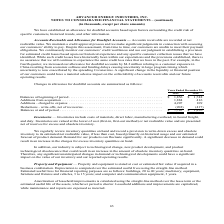According to Advanced Energy's financial document, What was the balance at the beginning of the period of 2019? According to the financial document, $1,856 (in thousands). The relevant text states: "Balances at beginning of period . $ 1,856 $ 1,748 Additions from acquisition . 1,884 416 Additions - charged to expense . 4,207 109 Deduction..." Also, What was the  Additions from acquisition of 2018? According to the financial document, 1,884 (in thousands). The relevant text states: "od . $ 1,856 $ 1,748 Additions from acquisition . 1,884 416 Additions - charged to expense . 4,207 109 Deductions - write-offs, net of recoveries . (202) (..." Also, How did the company establish an allowance for doubtful accounts? based upon factors surrounding the credit risk of specific customers, historical trends, and other information.. The document states: "ave established an allowance for doubtful accounts based upon factors surrounding the credit risk of specific customers, historical trends, and other ..." Also, can you calculate: What were the changes in Additions from acquisition between 2018 and 2019? Based on the calculation: 1,884-416, the result is 1468 (in thousands). This is based on the information: "1,856 $ 1,748 Additions from acquisition . 1,884 416 Additions - charged to expense . 4,207 109 Deductions - write-offs, net of recoveries . (202) (417) od . $ 1,856 $ 1,748 Additions from acquisition..." The key data points involved are: 1,884, 416. Also, can you calculate: What was the change in balances at the end of period between 2018 and 2019? Based on the calculation: $7,745-$1,856, the result is 5889 (in thousands). This is based on the information: "eries . (202) (417) Balances at end of period . $ 7,745 $ 1,856 Inventories — Inventories include costs of materials, direct labor, manufacturing overhead, Balances at beginning of period . $ 1,856 $ ..." The key data points involved are: 1,856, 7,745. Also, can you calculate: What was the percentage change in the balances at beginning of period between 2018 and 2019? To answer this question, I need to perform calculations using the financial data. The calculation is: ($1,856-$1,748)/$1,748, which equals 6.18 (percentage). This is based on the information: "Balances at beginning of period . $ 1,856 $ 1,748 Additions from acquisition . 1,884 416 Additions - charged to expense . 4,207 109 Deduction Balances at beginning of period . $ 1,856 $ 1,748 Addition..." The key data points involved are: 1,748, 1,856. 